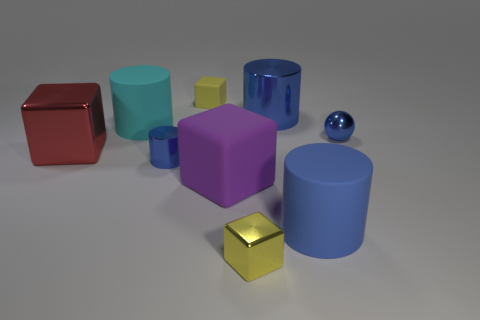Subtract all purple blocks. How many blue cylinders are left? 3 Add 1 blue matte things. How many objects exist? 10 Subtract all blocks. How many objects are left? 5 Subtract all large blue rubber things. Subtract all tiny cylinders. How many objects are left? 7 Add 1 small matte cubes. How many small matte cubes are left? 2 Add 7 large gray matte cylinders. How many large gray matte cylinders exist? 7 Subtract 2 yellow blocks. How many objects are left? 7 